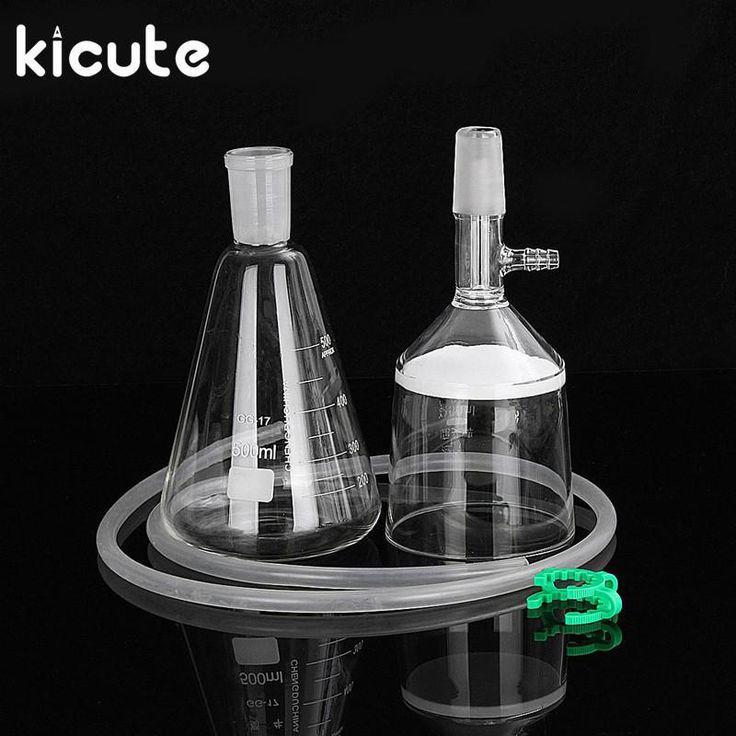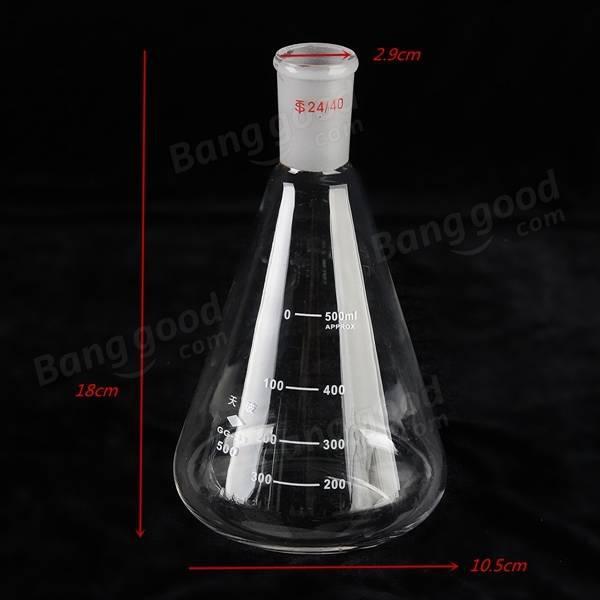The first image is the image on the left, the second image is the image on the right. Examine the images to the left and right. Is the description "There are exactly three flasks in the image on the left." accurate? Answer yes or no. No. 